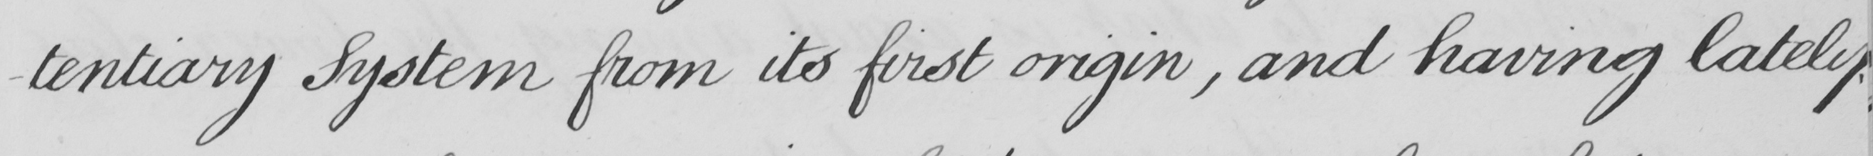Please transcribe the handwritten text in this image. -tentiary System from its first origin , and having lately 